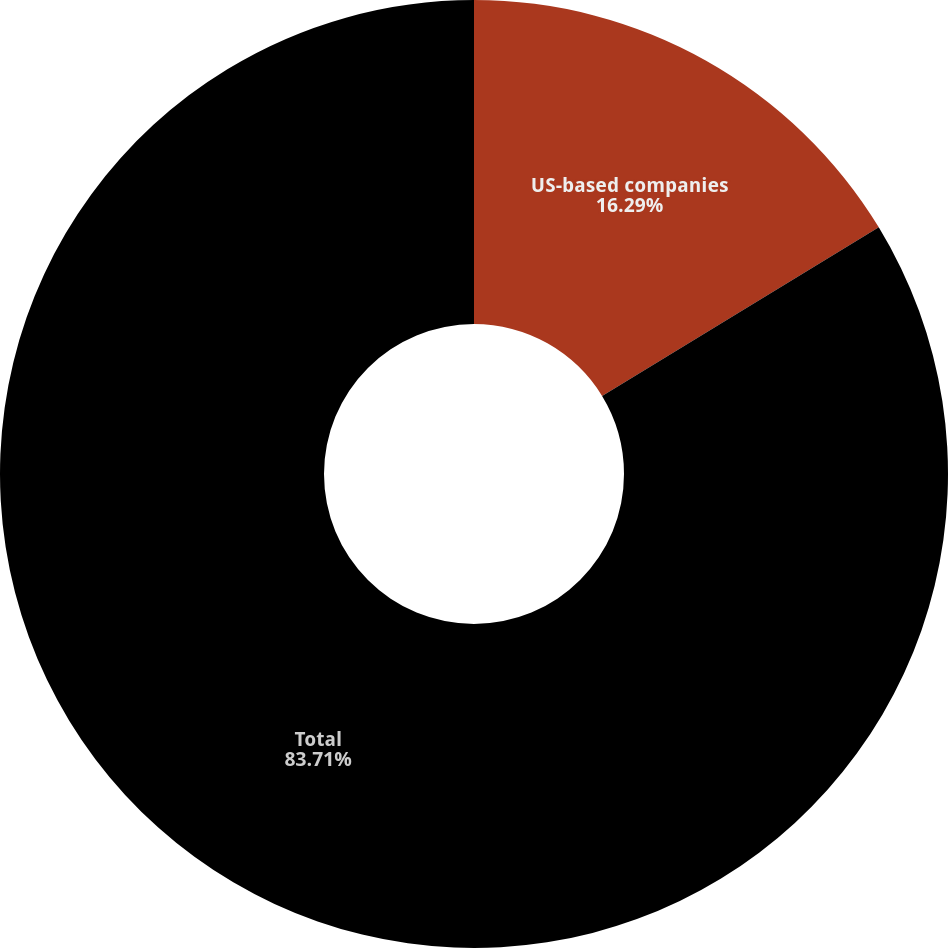Convert chart to OTSL. <chart><loc_0><loc_0><loc_500><loc_500><pie_chart><fcel>US-based companies<fcel>Total<nl><fcel>16.29%<fcel>83.71%<nl></chart> 